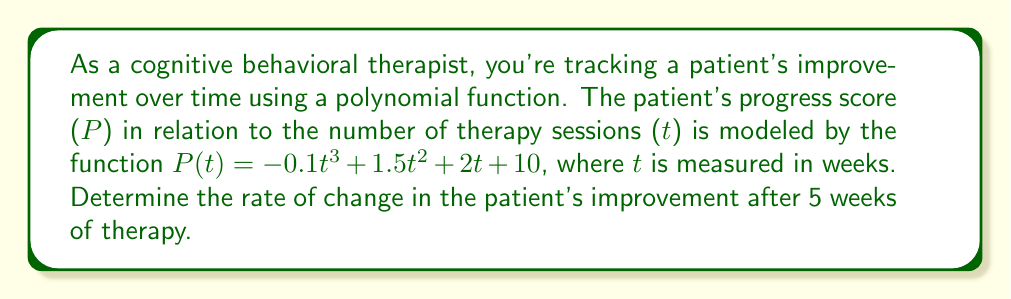Give your solution to this math problem. To find the rate of change in the patient's improvement after 5 weeks, we need to calculate the derivative of the given function and evaluate it at t = 5. Here's the step-by-step process:

1) The given function is: $P(t) = -0.1t^3 + 1.5t^2 + 2t + 10$

2) To find the rate of change, we need to find $P'(t)$, the derivative of $P(t)$:
   $P'(t) = \frac{d}{dt}(-0.1t^3 + 1.5t^2 + 2t + 10)$

3) Using the power rule and constant rule of derivatives:
   $P'(t) = -0.3t^2 + 3t + 2$

4) Now, we need to evaluate $P'(5)$ to find the rate of change at 5 weeks:
   $P'(5) = -0.3(5^2) + 3(5) + 2$

5) Simplify:
   $P'(5) = -0.3(25) + 15 + 2$
   $P'(5) = -7.5 + 15 + 2$
   $P'(5) = 9.5$

The rate of change after 5 weeks is 9.5 points per week.
Answer: 9.5 points per week 